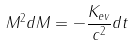Convert formula to latex. <formula><loc_0><loc_0><loc_500><loc_500>M ^ { 2 } d M = - \frac { K _ { e v } } { c ^ { 2 } } d t</formula> 